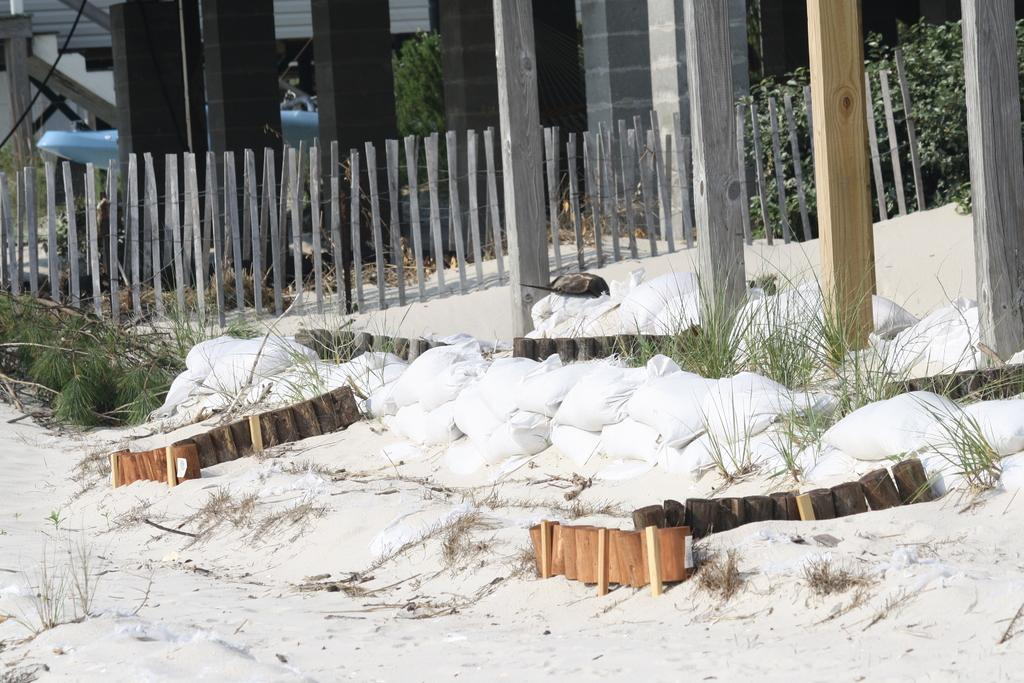What objects are placed on the snow in the image? There are wood blocks placed on the snow. What can be seen on the right side of the image? There is a wooden fence on the right side of the image. What is visible in the background of the image? There is a building and a staircase in the background of the image. What type of trade is being conducted in the image? There is no indication of any trade being conducted in the image. What religious symbol can be seen on the wood blocks? There is no religious symbol present on the wood blocks in the image. 